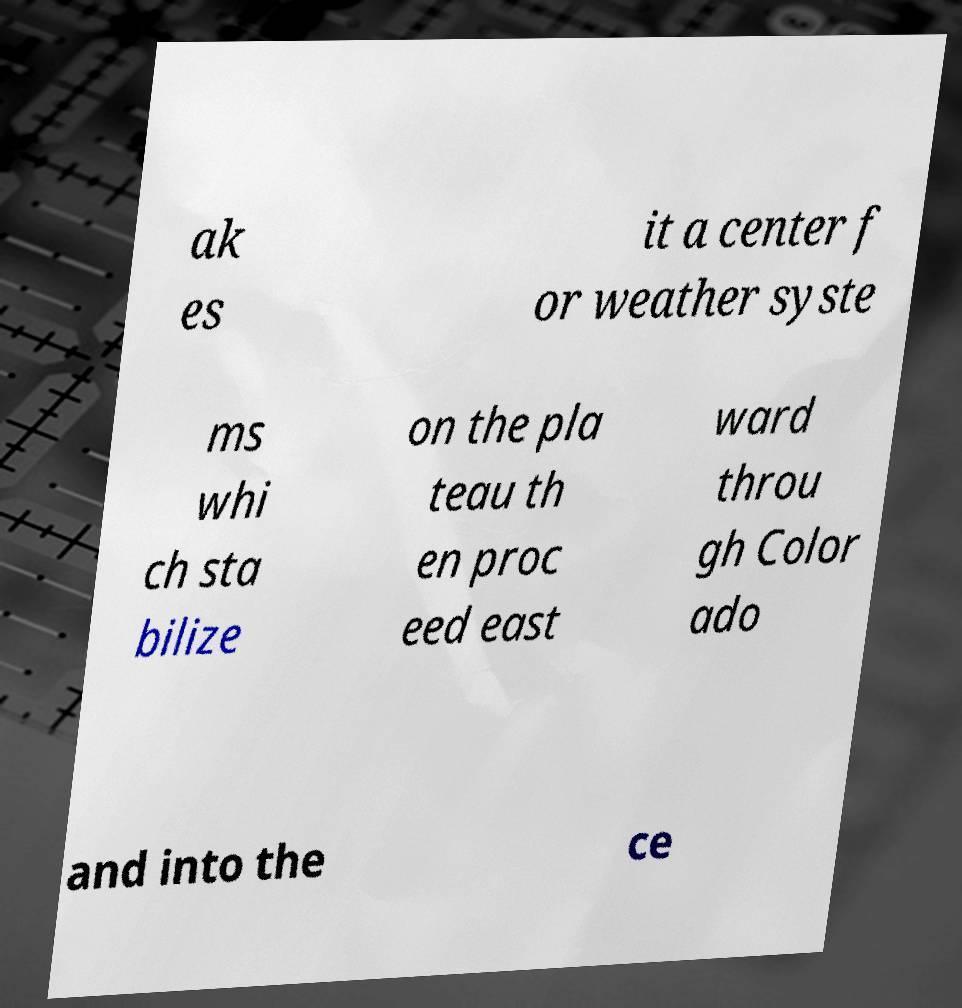Can you accurately transcribe the text from the provided image for me? ak es it a center f or weather syste ms whi ch sta bilize on the pla teau th en proc eed east ward throu gh Color ado and into the ce 